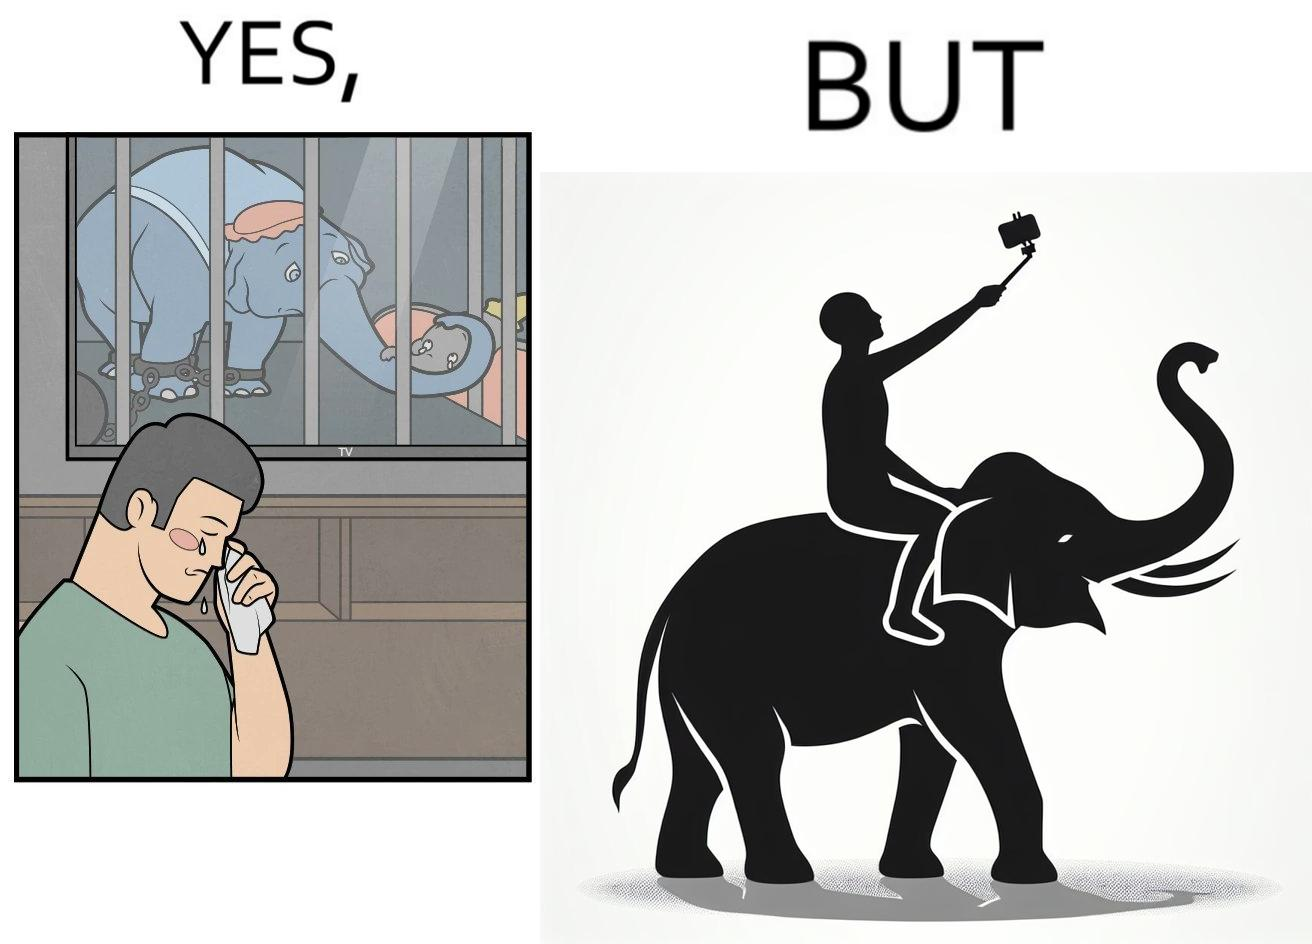Describe what you see in this image. The image is ironic, because the people who get sentimental over imprisoned animal while watching TV shows often feel okay when using animals for labor 